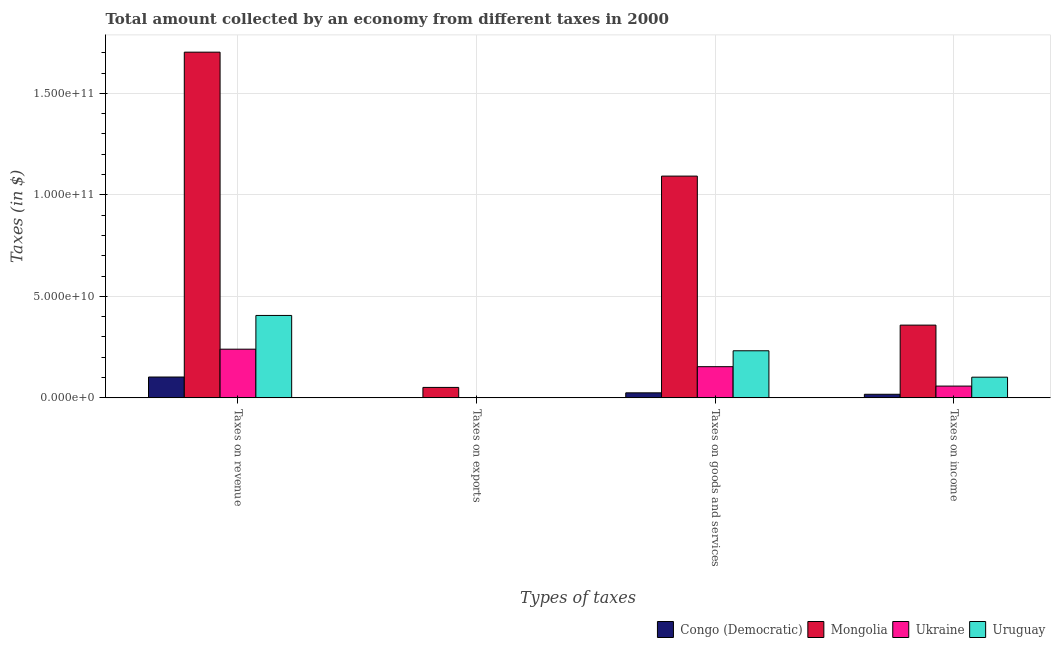How many different coloured bars are there?
Keep it short and to the point. 4. How many bars are there on the 4th tick from the left?
Offer a very short reply. 4. What is the label of the 3rd group of bars from the left?
Offer a terse response. Taxes on goods and services. What is the amount collected as tax on exports in Ukraine?
Make the answer very short. 5.60e+06. Across all countries, what is the maximum amount collected as tax on revenue?
Your response must be concise. 1.70e+11. Across all countries, what is the minimum amount collected as tax on revenue?
Your response must be concise. 1.03e+1. In which country was the amount collected as tax on revenue maximum?
Provide a succinct answer. Mongolia. In which country was the amount collected as tax on exports minimum?
Give a very brief answer. Ukraine. What is the total amount collected as tax on exports in the graph?
Make the answer very short. 5.33e+09. What is the difference between the amount collected as tax on goods in Ukraine and that in Uruguay?
Your answer should be compact. -7.84e+09. What is the difference between the amount collected as tax on goods in Congo (Democratic) and the amount collected as tax on revenue in Uruguay?
Provide a short and direct response. -3.81e+1. What is the average amount collected as tax on goods per country?
Provide a short and direct response. 3.76e+1. What is the difference between the amount collected as tax on income and amount collected as tax on exports in Ukraine?
Ensure brevity in your answer.  5.80e+09. In how many countries, is the amount collected as tax on goods greater than 20000000000 $?
Provide a short and direct response. 2. What is the ratio of the amount collected as tax on goods in Uruguay to that in Congo (Democratic)?
Make the answer very short. 9.36. Is the amount collected as tax on income in Mongolia less than that in Uruguay?
Your answer should be very brief. No. Is the difference between the amount collected as tax on revenue in Uruguay and Mongolia greater than the difference between the amount collected as tax on income in Uruguay and Mongolia?
Provide a short and direct response. No. What is the difference between the highest and the second highest amount collected as tax on income?
Make the answer very short. 2.56e+1. What is the difference between the highest and the lowest amount collected as tax on revenue?
Your response must be concise. 1.60e+11. Is the sum of the amount collected as tax on revenue in Ukraine and Uruguay greater than the maximum amount collected as tax on exports across all countries?
Keep it short and to the point. Yes. Is it the case that in every country, the sum of the amount collected as tax on revenue and amount collected as tax on exports is greater than the sum of amount collected as tax on goods and amount collected as tax on income?
Keep it short and to the point. No. What does the 4th bar from the left in Taxes on revenue represents?
Give a very brief answer. Uruguay. What does the 1st bar from the right in Taxes on income represents?
Offer a terse response. Uruguay. How many bars are there?
Ensure brevity in your answer.  16. How many countries are there in the graph?
Offer a terse response. 4. What is the difference between two consecutive major ticks on the Y-axis?
Offer a terse response. 5.00e+1. Are the values on the major ticks of Y-axis written in scientific E-notation?
Offer a very short reply. Yes. Does the graph contain any zero values?
Your response must be concise. No. Does the graph contain grids?
Offer a very short reply. Yes. How are the legend labels stacked?
Offer a terse response. Horizontal. What is the title of the graph?
Offer a very short reply. Total amount collected by an economy from different taxes in 2000. Does "Thailand" appear as one of the legend labels in the graph?
Your answer should be very brief. No. What is the label or title of the X-axis?
Provide a succinct answer. Types of taxes. What is the label or title of the Y-axis?
Offer a terse response. Taxes (in $). What is the Taxes (in $) in Congo (Democratic) in Taxes on revenue?
Your answer should be very brief. 1.03e+1. What is the Taxes (in $) of Mongolia in Taxes on revenue?
Make the answer very short. 1.70e+11. What is the Taxes (in $) in Ukraine in Taxes on revenue?
Keep it short and to the point. 2.40e+1. What is the Taxes (in $) of Uruguay in Taxes on revenue?
Your answer should be very brief. 4.06e+1. What is the Taxes (in $) of Congo (Democratic) in Taxes on exports?
Your response must be concise. 1.15e+08. What is the Taxes (in $) in Mongolia in Taxes on exports?
Keep it short and to the point. 5.15e+09. What is the Taxes (in $) of Ukraine in Taxes on exports?
Provide a short and direct response. 5.60e+06. What is the Taxes (in $) in Uruguay in Taxes on exports?
Give a very brief answer. 5.60e+07. What is the Taxes (in $) of Congo (Democratic) in Taxes on goods and services?
Ensure brevity in your answer.  2.48e+09. What is the Taxes (in $) in Mongolia in Taxes on goods and services?
Keep it short and to the point. 1.09e+11. What is the Taxes (in $) of Ukraine in Taxes on goods and services?
Ensure brevity in your answer.  1.54e+1. What is the Taxes (in $) in Uruguay in Taxes on goods and services?
Provide a succinct answer. 2.32e+1. What is the Taxes (in $) in Congo (Democratic) in Taxes on income?
Offer a very short reply. 1.77e+09. What is the Taxes (in $) of Mongolia in Taxes on income?
Offer a terse response. 3.58e+1. What is the Taxes (in $) in Ukraine in Taxes on income?
Your response must be concise. 5.80e+09. What is the Taxes (in $) of Uruguay in Taxes on income?
Ensure brevity in your answer.  1.02e+1. Across all Types of taxes, what is the maximum Taxes (in $) of Congo (Democratic)?
Ensure brevity in your answer.  1.03e+1. Across all Types of taxes, what is the maximum Taxes (in $) of Mongolia?
Keep it short and to the point. 1.70e+11. Across all Types of taxes, what is the maximum Taxes (in $) of Ukraine?
Ensure brevity in your answer.  2.40e+1. Across all Types of taxes, what is the maximum Taxes (in $) of Uruguay?
Your answer should be compact. 4.06e+1. Across all Types of taxes, what is the minimum Taxes (in $) in Congo (Democratic)?
Make the answer very short. 1.15e+08. Across all Types of taxes, what is the minimum Taxes (in $) of Mongolia?
Make the answer very short. 5.15e+09. Across all Types of taxes, what is the minimum Taxes (in $) of Ukraine?
Your answer should be very brief. 5.60e+06. Across all Types of taxes, what is the minimum Taxes (in $) of Uruguay?
Give a very brief answer. 5.60e+07. What is the total Taxes (in $) in Congo (Democratic) in the graph?
Your response must be concise. 1.46e+1. What is the total Taxes (in $) of Mongolia in the graph?
Provide a succinct answer. 3.20e+11. What is the total Taxes (in $) of Ukraine in the graph?
Provide a short and direct response. 4.52e+1. What is the total Taxes (in $) in Uruguay in the graph?
Keep it short and to the point. 7.40e+1. What is the difference between the Taxes (in $) in Congo (Democratic) in Taxes on revenue and that in Taxes on exports?
Keep it short and to the point. 1.02e+1. What is the difference between the Taxes (in $) of Mongolia in Taxes on revenue and that in Taxes on exports?
Keep it short and to the point. 1.65e+11. What is the difference between the Taxes (in $) in Ukraine in Taxes on revenue and that in Taxes on exports?
Offer a very short reply. 2.40e+1. What is the difference between the Taxes (in $) of Uruguay in Taxes on revenue and that in Taxes on exports?
Provide a short and direct response. 4.05e+1. What is the difference between the Taxes (in $) in Congo (Democratic) in Taxes on revenue and that in Taxes on goods and services?
Give a very brief answer. 7.79e+09. What is the difference between the Taxes (in $) of Mongolia in Taxes on revenue and that in Taxes on goods and services?
Your answer should be very brief. 6.10e+1. What is the difference between the Taxes (in $) of Ukraine in Taxes on revenue and that in Taxes on goods and services?
Keep it short and to the point. 8.62e+09. What is the difference between the Taxes (in $) of Uruguay in Taxes on revenue and that in Taxes on goods and services?
Provide a short and direct response. 1.74e+1. What is the difference between the Taxes (in $) in Congo (Democratic) in Taxes on revenue and that in Taxes on income?
Your answer should be compact. 8.50e+09. What is the difference between the Taxes (in $) in Mongolia in Taxes on revenue and that in Taxes on income?
Your answer should be very brief. 1.34e+11. What is the difference between the Taxes (in $) of Ukraine in Taxes on revenue and that in Taxes on income?
Your answer should be compact. 1.82e+1. What is the difference between the Taxes (in $) in Uruguay in Taxes on revenue and that in Taxes on income?
Give a very brief answer. 3.04e+1. What is the difference between the Taxes (in $) in Congo (Democratic) in Taxes on exports and that in Taxes on goods and services?
Offer a terse response. -2.36e+09. What is the difference between the Taxes (in $) of Mongolia in Taxes on exports and that in Taxes on goods and services?
Offer a terse response. -1.04e+11. What is the difference between the Taxes (in $) of Ukraine in Taxes on exports and that in Taxes on goods and services?
Provide a succinct answer. -1.54e+1. What is the difference between the Taxes (in $) of Uruguay in Taxes on exports and that in Taxes on goods and services?
Give a very brief answer. -2.31e+1. What is the difference between the Taxes (in $) of Congo (Democratic) in Taxes on exports and that in Taxes on income?
Provide a short and direct response. -1.65e+09. What is the difference between the Taxes (in $) in Mongolia in Taxes on exports and that in Taxes on income?
Your answer should be very brief. -3.07e+1. What is the difference between the Taxes (in $) in Ukraine in Taxes on exports and that in Taxes on income?
Offer a very short reply. -5.80e+09. What is the difference between the Taxes (in $) of Uruguay in Taxes on exports and that in Taxes on income?
Keep it short and to the point. -1.01e+1. What is the difference between the Taxes (in $) of Congo (Democratic) in Taxes on goods and services and that in Taxes on income?
Offer a very short reply. 7.10e+08. What is the difference between the Taxes (in $) of Mongolia in Taxes on goods and services and that in Taxes on income?
Your answer should be very brief. 7.34e+1. What is the difference between the Taxes (in $) in Ukraine in Taxes on goods and services and that in Taxes on income?
Provide a short and direct response. 9.56e+09. What is the difference between the Taxes (in $) of Uruguay in Taxes on goods and services and that in Taxes on income?
Make the answer very short. 1.30e+1. What is the difference between the Taxes (in $) of Congo (Democratic) in Taxes on revenue and the Taxes (in $) of Mongolia in Taxes on exports?
Give a very brief answer. 5.12e+09. What is the difference between the Taxes (in $) in Congo (Democratic) in Taxes on revenue and the Taxes (in $) in Ukraine in Taxes on exports?
Provide a short and direct response. 1.03e+1. What is the difference between the Taxes (in $) of Congo (Democratic) in Taxes on revenue and the Taxes (in $) of Uruguay in Taxes on exports?
Keep it short and to the point. 1.02e+1. What is the difference between the Taxes (in $) in Mongolia in Taxes on revenue and the Taxes (in $) in Ukraine in Taxes on exports?
Keep it short and to the point. 1.70e+11. What is the difference between the Taxes (in $) in Mongolia in Taxes on revenue and the Taxes (in $) in Uruguay in Taxes on exports?
Offer a very short reply. 1.70e+11. What is the difference between the Taxes (in $) in Ukraine in Taxes on revenue and the Taxes (in $) in Uruguay in Taxes on exports?
Provide a succinct answer. 2.39e+1. What is the difference between the Taxes (in $) of Congo (Democratic) in Taxes on revenue and the Taxes (in $) of Mongolia in Taxes on goods and services?
Provide a short and direct response. -9.90e+1. What is the difference between the Taxes (in $) of Congo (Democratic) in Taxes on revenue and the Taxes (in $) of Ukraine in Taxes on goods and services?
Ensure brevity in your answer.  -5.09e+09. What is the difference between the Taxes (in $) in Congo (Democratic) in Taxes on revenue and the Taxes (in $) in Uruguay in Taxes on goods and services?
Your answer should be very brief. -1.29e+1. What is the difference between the Taxes (in $) in Mongolia in Taxes on revenue and the Taxes (in $) in Ukraine in Taxes on goods and services?
Give a very brief answer. 1.55e+11. What is the difference between the Taxes (in $) in Mongolia in Taxes on revenue and the Taxes (in $) in Uruguay in Taxes on goods and services?
Provide a succinct answer. 1.47e+11. What is the difference between the Taxes (in $) in Ukraine in Taxes on revenue and the Taxes (in $) in Uruguay in Taxes on goods and services?
Keep it short and to the point. 7.82e+08. What is the difference between the Taxes (in $) in Congo (Democratic) in Taxes on revenue and the Taxes (in $) in Mongolia in Taxes on income?
Give a very brief answer. -2.56e+1. What is the difference between the Taxes (in $) of Congo (Democratic) in Taxes on revenue and the Taxes (in $) of Ukraine in Taxes on income?
Provide a succinct answer. 4.47e+09. What is the difference between the Taxes (in $) of Congo (Democratic) in Taxes on revenue and the Taxes (in $) of Uruguay in Taxes on income?
Provide a succinct answer. 7.53e+07. What is the difference between the Taxes (in $) in Mongolia in Taxes on revenue and the Taxes (in $) in Ukraine in Taxes on income?
Give a very brief answer. 1.64e+11. What is the difference between the Taxes (in $) in Mongolia in Taxes on revenue and the Taxes (in $) in Uruguay in Taxes on income?
Ensure brevity in your answer.  1.60e+11. What is the difference between the Taxes (in $) of Ukraine in Taxes on revenue and the Taxes (in $) of Uruguay in Taxes on income?
Offer a very short reply. 1.38e+1. What is the difference between the Taxes (in $) of Congo (Democratic) in Taxes on exports and the Taxes (in $) of Mongolia in Taxes on goods and services?
Ensure brevity in your answer.  -1.09e+11. What is the difference between the Taxes (in $) of Congo (Democratic) in Taxes on exports and the Taxes (in $) of Ukraine in Taxes on goods and services?
Give a very brief answer. -1.52e+1. What is the difference between the Taxes (in $) of Congo (Democratic) in Taxes on exports and the Taxes (in $) of Uruguay in Taxes on goods and services?
Offer a terse response. -2.31e+1. What is the difference between the Taxes (in $) in Mongolia in Taxes on exports and the Taxes (in $) in Ukraine in Taxes on goods and services?
Ensure brevity in your answer.  -1.02e+1. What is the difference between the Taxes (in $) of Mongolia in Taxes on exports and the Taxes (in $) of Uruguay in Taxes on goods and services?
Provide a succinct answer. -1.80e+1. What is the difference between the Taxes (in $) of Ukraine in Taxes on exports and the Taxes (in $) of Uruguay in Taxes on goods and services?
Give a very brief answer. -2.32e+1. What is the difference between the Taxes (in $) in Congo (Democratic) in Taxes on exports and the Taxes (in $) in Mongolia in Taxes on income?
Provide a short and direct response. -3.57e+1. What is the difference between the Taxes (in $) of Congo (Democratic) in Taxes on exports and the Taxes (in $) of Ukraine in Taxes on income?
Your answer should be compact. -5.69e+09. What is the difference between the Taxes (in $) in Congo (Democratic) in Taxes on exports and the Taxes (in $) in Uruguay in Taxes on income?
Offer a very short reply. -1.01e+1. What is the difference between the Taxes (in $) of Mongolia in Taxes on exports and the Taxes (in $) of Ukraine in Taxes on income?
Offer a very short reply. -6.49e+08. What is the difference between the Taxes (in $) of Mongolia in Taxes on exports and the Taxes (in $) of Uruguay in Taxes on income?
Keep it short and to the point. -5.04e+09. What is the difference between the Taxes (in $) of Ukraine in Taxes on exports and the Taxes (in $) of Uruguay in Taxes on income?
Provide a short and direct response. -1.02e+1. What is the difference between the Taxes (in $) of Congo (Democratic) in Taxes on goods and services and the Taxes (in $) of Mongolia in Taxes on income?
Offer a terse response. -3.34e+1. What is the difference between the Taxes (in $) in Congo (Democratic) in Taxes on goods and services and the Taxes (in $) in Ukraine in Taxes on income?
Provide a succinct answer. -3.32e+09. What is the difference between the Taxes (in $) of Congo (Democratic) in Taxes on goods and services and the Taxes (in $) of Uruguay in Taxes on income?
Give a very brief answer. -7.72e+09. What is the difference between the Taxes (in $) in Mongolia in Taxes on goods and services and the Taxes (in $) in Ukraine in Taxes on income?
Your answer should be compact. 1.03e+11. What is the difference between the Taxes (in $) in Mongolia in Taxes on goods and services and the Taxes (in $) in Uruguay in Taxes on income?
Ensure brevity in your answer.  9.90e+1. What is the difference between the Taxes (in $) of Ukraine in Taxes on goods and services and the Taxes (in $) of Uruguay in Taxes on income?
Give a very brief answer. 5.17e+09. What is the average Taxes (in $) in Congo (Democratic) per Types of taxes?
Offer a very short reply. 3.66e+09. What is the average Taxes (in $) in Mongolia per Types of taxes?
Offer a terse response. 8.01e+1. What is the average Taxes (in $) in Ukraine per Types of taxes?
Make the answer very short. 1.13e+1. What is the average Taxes (in $) in Uruguay per Types of taxes?
Offer a terse response. 1.85e+1. What is the difference between the Taxes (in $) in Congo (Democratic) and Taxes (in $) in Mongolia in Taxes on revenue?
Make the answer very short. -1.60e+11. What is the difference between the Taxes (in $) of Congo (Democratic) and Taxes (in $) of Ukraine in Taxes on revenue?
Ensure brevity in your answer.  -1.37e+1. What is the difference between the Taxes (in $) in Congo (Democratic) and Taxes (in $) in Uruguay in Taxes on revenue?
Your answer should be very brief. -3.03e+1. What is the difference between the Taxes (in $) in Mongolia and Taxes (in $) in Ukraine in Taxes on revenue?
Provide a succinct answer. 1.46e+11. What is the difference between the Taxes (in $) of Mongolia and Taxes (in $) of Uruguay in Taxes on revenue?
Your answer should be compact. 1.30e+11. What is the difference between the Taxes (in $) of Ukraine and Taxes (in $) of Uruguay in Taxes on revenue?
Provide a short and direct response. -1.66e+1. What is the difference between the Taxes (in $) of Congo (Democratic) and Taxes (in $) of Mongolia in Taxes on exports?
Make the answer very short. -5.04e+09. What is the difference between the Taxes (in $) in Congo (Democratic) and Taxes (in $) in Ukraine in Taxes on exports?
Your answer should be very brief. 1.09e+08. What is the difference between the Taxes (in $) in Congo (Democratic) and Taxes (in $) in Uruguay in Taxes on exports?
Give a very brief answer. 5.89e+07. What is the difference between the Taxes (in $) of Mongolia and Taxes (in $) of Ukraine in Taxes on exports?
Offer a very short reply. 5.15e+09. What is the difference between the Taxes (in $) of Mongolia and Taxes (in $) of Uruguay in Taxes on exports?
Provide a short and direct response. 5.10e+09. What is the difference between the Taxes (in $) of Ukraine and Taxes (in $) of Uruguay in Taxes on exports?
Ensure brevity in your answer.  -5.04e+07. What is the difference between the Taxes (in $) in Congo (Democratic) and Taxes (in $) in Mongolia in Taxes on goods and services?
Provide a succinct answer. -1.07e+11. What is the difference between the Taxes (in $) of Congo (Democratic) and Taxes (in $) of Ukraine in Taxes on goods and services?
Offer a terse response. -1.29e+1. What is the difference between the Taxes (in $) of Congo (Democratic) and Taxes (in $) of Uruguay in Taxes on goods and services?
Give a very brief answer. -2.07e+1. What is the difference between the Taxes (in $) in Mongolia and Taxes (in $) in Ukraine in Taxes on goods and services?
Provide a succinct answer. 9.39e+1. What is the difference between the Taxes (in $) in Mongolia and Taxes (in $) in Uruguay in Taxes on goods and services?
Offer a terse response. 8.60e+1. What is the difference between the Taxes (in $) in Ukraine and Taxes (in $) in Uruguay in Taxes on goods and services?
Your response must be concise. -7.84e+09. What is the difference between the Taxes (in $) in Congo (Democratic) and Taxes (in $) in Mongolia in Taxes on income?
Keep it short and to the point. -3.41e+1. What is the difference between the Taxes (in $) in Congo (Democratic) and Taxes (in $) in Ukraine in Taxes on income?
Provide a succinct answer. -4.03e+09. What is the difference between the Taxes (in $) of Congo (Democratic) and Taxes (in $) of Uruguay in Taxes on income?
Give a very brief answer. -8.43e+09. What is the difference between the Taxes (in $) in Mongolia and Taxes (in $) in Ukraine in Taxes on income?
Your answer should be very brief. 3.00e+1. What is the difference between the Taxes (in $) of Mongolia and Taxes (in $) of Uruguay in Taxes on income?
Provide a succinct answer. 2.56e+1. What is the difference between the Taxes (in $) of Ukraine and Taxes (in $) of Uruguay in Taxes on income?
Offer a terse response. -4.39e+09. What is the ratio of the Taxes (in $) in Congo (Democratic) in Taxes on revenue to that in Taxes on exports?
Offer a very short reply. 89.39. What is the ratio of the Taxes (in $) in Mongolia in Taxes on revenue to that in Taxes on exports?
Keep it short and to the point. 33.04. What is the ratio of the Taxes (in $) of Ukraine in Taxes on revenue to that in Taxes on exports?
Ensure brevity in your answer.  4282.23. What is the ratio of the Taxes (in $) of Uruguay in Taxes on revenue to that in Taxes on exports?
Make the answer very short. 724.86. What is the ratio of the Taxes (in $) in Congo (Democratic) in Taxes on revenue to that in Taxes on goods and services?
Offer a very short reply. 4.15. What is the ratio of the Taxes (in $) of Mongolia in Taxes on revenue to that in Taxes on goods and services?
Make the answer very short. 1.56. What is the ratio of the Taxes (in $) in Ukraine in Taxes on revenue to that in Taxes on goods and services?
Your response must be concise. 1.56. What is the ratio of the Taxes (in $) in Uruguay in Taxes on revenue to that in Taxes on goods and services?
Keep it short and to the point. 1.75. What is the ratio of the Taxes (in $) of Congo (Democratic) in Taxes on revenue to that in Taxes on income?
Your response must be concise. 5.81. What is the ratio of the Taxes (in $) in Mongolia in Taxes on revenue to that in Taxes on income?
Provide a short and direct response. 4.75. What is the ratio of the Taxes (in $) in Ukraine in Taxes on revenue to that in Taxes on income?
Provide a succinct answer. 4.13. What is the ratio of the Taxes (in $) of Uruguay in Taxes on revenue to that in Taxes on income?
Keep it short and to the point. 3.98. What is the ratio of the Taxes (in $) in Congo (Democratic) in Taxes on exports to that in Taxes on goods and services?
Provide a short and direct response. 0.05. What is the ratio of the Taxes (in $) of Mongolia in Taxes on exports to that in Taxes on goods and services?
Offer a very short reply. 0.05. What is the ratio of the Taxes (in $) in Ukraine in Taxes on exports to that in Taxes on goods and services?
Offer a very short reply. 0. What is the ratio of the Taxes (in $) of Uruguay in Taxes on exports to that in Taxes on goods and services?
Offer a terse response. 0. What is the ratio of the Taxes (in $) of Congo (Democratic) in Taxes on exports to that in Taxes on income?
Provide a succinct answer. 0.07. What is the ratio of the Taxes (in $) in Mongolia in Taxes on exports to that in Taxes on income?
Provide a succinct answer. 0.14. What is the ratio of the Taxes (in $) in Uruguay in Taxes on exports to that in Taxes on income?
Your answer should be compact. 0.01. What is the ratio of the Taxes (in $) in Congo (Democratic) in Taxes on goods and services to that in Taxes on income?
Offer a very short reply. 1.4. What is the ratio of the Taxes (in $) of Mongolia in Taxes on goods and services to that in Taxes on income?
Your answer should be compact. 3.05. What is the ratio of the Taxes (in $) in Ukraine in Taxes on goods and services to that in Taxes on income?
Ensure brevity in your answer.  2.65. What is the ratio of the Taxes (in $) of Uruguay in Taxes on goods and services to that in Taxes on income?
Your response must be concise. 2.28. What is the difference between the highest and the second highest Taxes (in $) in Congo (Democratic)?
Offer a very short reply. 7.79e+09. What is the difference between the highest and the second highest Taxes (in $) in Mongolia?
Give a very brief answer. 6.10e+1. What is the difference between the highest and the second highest Taxes (in $) of Ukraine?
Your answer should be compact. 8.62e+09. What is the difference between the highest and the second highest Taxes (in $) in Uruguay?
Your answer should be very brief. 1.74e+1. What is the difference between the highest and the lowest Taxes (in $) in Congo (Democratic)?
Offer a terse response. 1.02e+1. What is the difference between the highest and the lowest Taxes (in $) of Mongolia?
Make the answer very short. 1.65e+11. What is the difference between the highest and the lowest Taxes (in $) in Ukraine?
Keep it short and to the point. 2.40e+1. What is the difference between the highest and the lowest Taxes (in $) in Uruguay?
Make the answer very short. 4.05e+1. 